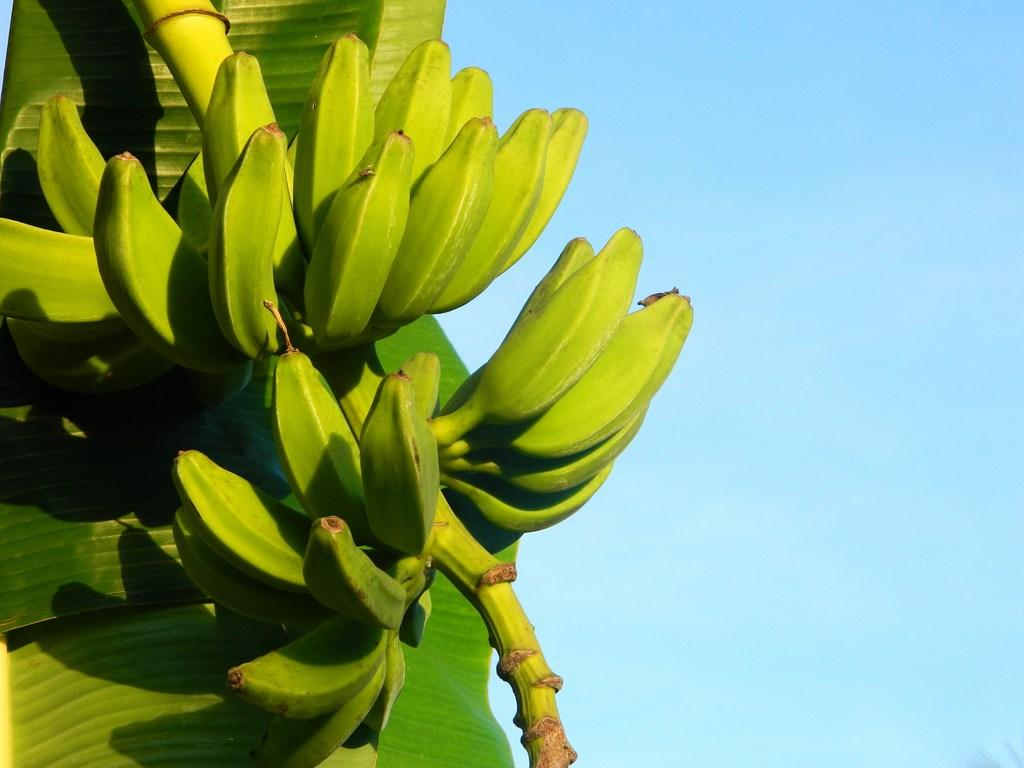What type of tree is present in the image? There is a banana tree in the image. How many minutes does it take for the thread to cut through the blade in the image? There is no thread, blade, or any action taking place in the image; it only features a banana tree. 